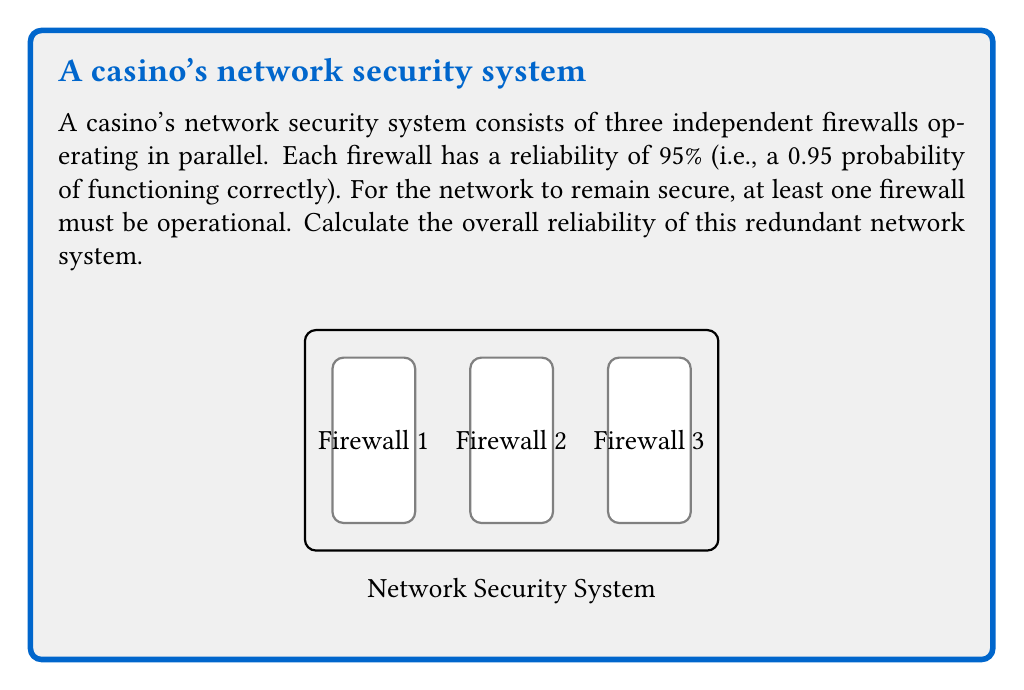Can you solve this math problem? To solve this problem, we'll use the concept of reliability in parallel systems and probability theory:

1) First, let's calculate the probability of a single firewall failing:
   $P(\text{failure}) = 1 - P(\text{success}) = 1 - 0.95 = 0.05$

2) For the entire system to fail, all three firewalls must fail simultaneously. The probability of this occurring is:
   $P(\text{all fail}) = 0.05 \times 0.05 \times 0.05 = 0.05^3 = 0.000125$

3) The reliability of the system is the opposite of the probability of all firewalls failing:
   $P(\text{system reliable}) = 1 - P(\text{all fail}) = 1 - 0.000125 = 0.999875$

4) To express this as a percentage:
   $0.999875 \times 100\% = 99.9875\%$

Therefore, the overall reliability of the redundant network system is 99.9875%.

This high reliability demonstrates the effectiveness of redundancy in improving system reliability. Even though each individual firewall is 95% reliable, the parallel configuration dramatically increases the overall system reliability to 99.9875%.
Answer: 99.9875% 